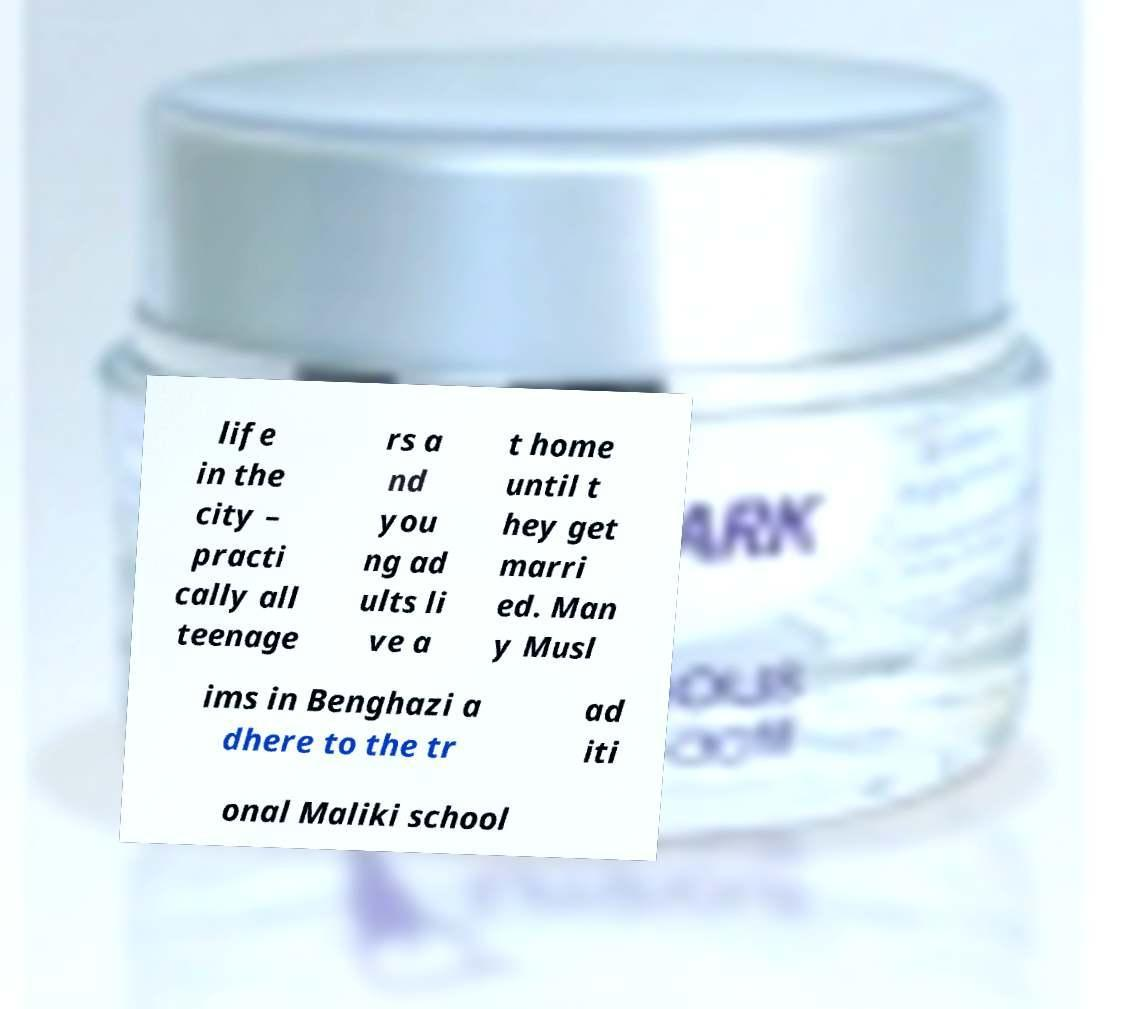What messages or text are displayed in this image? I need them in a readable, typed format. life in the city – practi cally all teenage rs a nd you ng ad ults li ve a t home until t hey get marri ed. Man y Musl ims in Benghazi a dhere to the tr ad iti onal Maliki school 